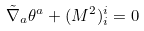Convert formula to latex. <formula><loc_0><loc_0><loc_500><loc_500>\tilde { \nabla } _ { a } \theta ^ { a } + ( M ^ { 2 } ) ^ { i } _ { i } = 0</formula> 